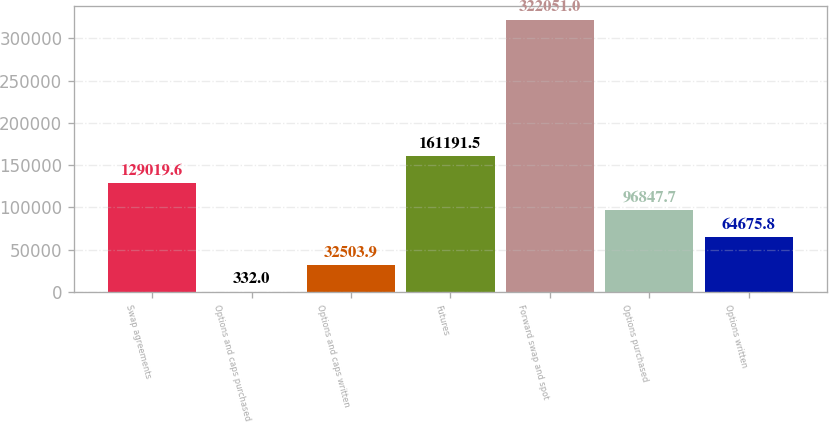Convert chart to OTSL. <chart><loc_0><loc_0><loc_500><loc_500><bar_chart><fcel>Swap agreements<fcel>Options and caps purchased<fcel>Options and caps written<fcel>Futures<fcel>Forward swap and spot<fcel>Options purchased<fcel>Options written<nl><fcel>129020<fcel>332<fcel>32503.9<fcel>161192<fcel>322051<fcel>96847.7<fcel>64675.8<nl></chart> 